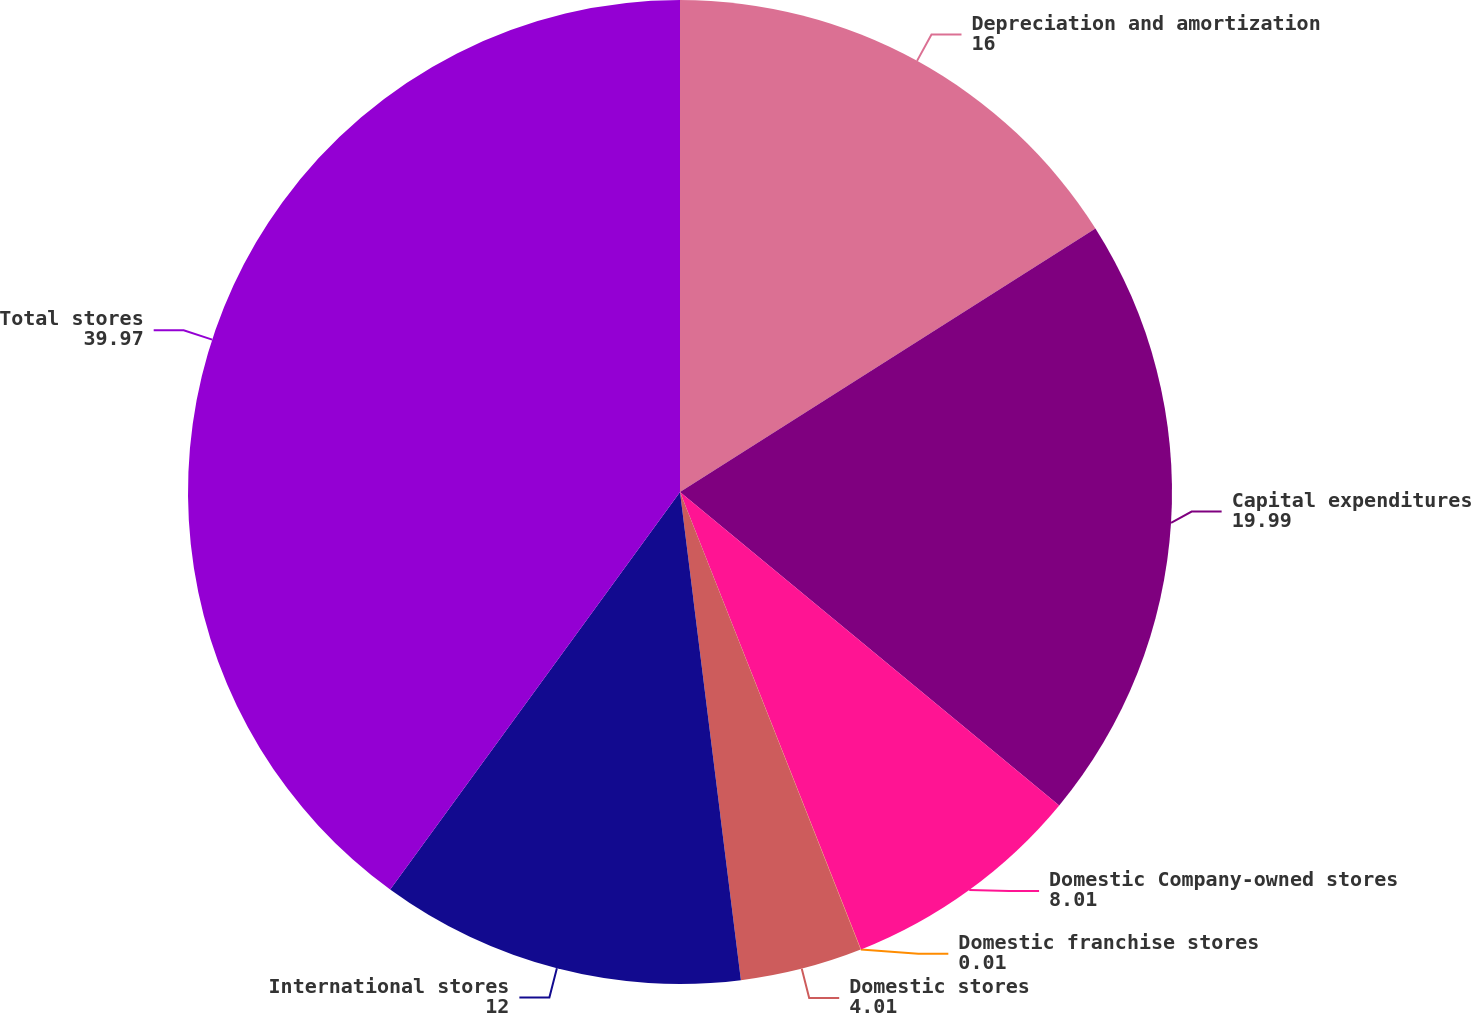Convert chart to OTSL. <chart><loc_0><loc_0><loc_500><loc_500><pie_chart><fcel>Depreciation and amortization<fcel>Capital expenditures<fcel>Domestic Company-owned stores<fcel>Domestic franchise stores<fcel>Domestic stores<fcel>International stores<fcel>Total stores<nl><fcel>16.0%<fcel>19.99%<fcel>8.01%<fcel>0.01%<fcel>4.01%<fcel>12.0%<fcel>39.97%<nl></chart> 